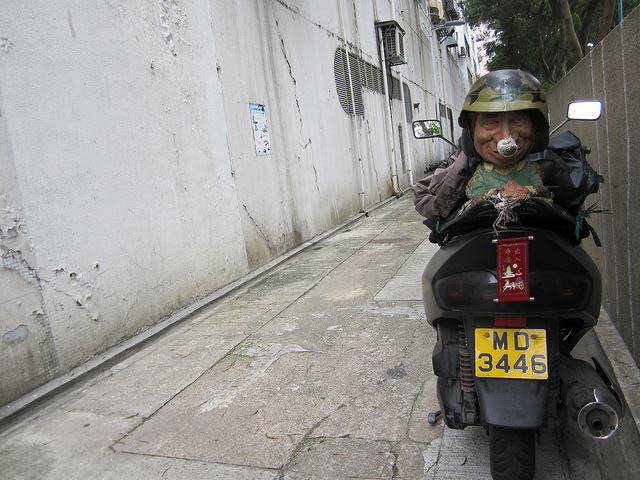Identify the text contained in this image. M D 3446 